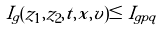Convert formula to latex. <formula><loc_0><loc_0><loc_500><loc_500>\tilde { I } _ { g } ( z _ { 1 } , z _ { 2 } , t , x , v ) \leq \tilde { I } _ { g p q }</formula> 